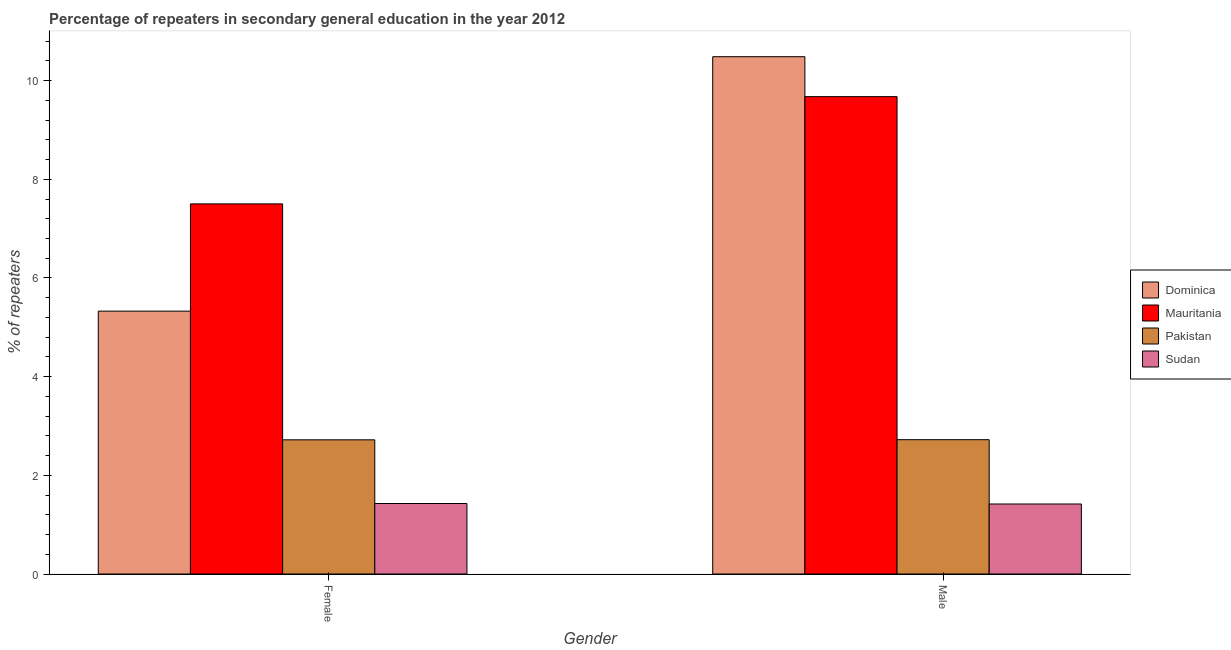How many groups of bars are there?
Give a very brief answer. 2. What is the label of the 2nd group of bars from the left?
Keep it short and to the point. Male. What is the percentage of female repeaters in Sudan?
Your answer should be compact. 1.43. Across all countries, what is the maximum percentage of male repeaters?
Make the answer very short. 10.49. Across all countries, what is the minimum percentage of female repeaters?
Provide a succinct answer. 1.43. In which country was the percentage of male repeaters maximum?
Make the answer very short. Dominica. In which country was the percentage of male repeaters minimum?
Offer a very short reply. Sudan. What is the total percentage of female repeaters in the graph?
Provide a succinct answer. 16.98. What is the difference between the percentage of female repeaters in Mauritania and that in Pakistan?
Offer a very short reply. 4.78. What is the difference between the percentage of female repeaters in Pakistan and the percentage of male repeaters in Dominica?
Offer a terse response. -7.77. What is the average percentage of female repeaters per country?
Offer a very short reply. 4.24. What is the difference between the percentage of male repeaters and percentage of female repeaters in Sudan?
Ensure brevity in your answer.  -0.01. In how many countries, is the percentage of female repeaters greater than 7.6 %?
Offer a terse response. 0. What is the ratio of the percentage of male repeaters in Pakistan to that in Sudan?
Offer a terse response. 1.92. Is the percentage of female repeaters in Mauritania less than that in Sudan?
Your answer should be compact. No. In how many countries, is the percentage of male repeaters greater than the average percentage of male repeaters taken over all countries?
Offer a very short reply. 2. What does the 1st bar from the left in Male represents?
Make the answer very short. Dominica. Are the values on the major ticks of Y-axis written in scientific E-notation?
Keep it short and to the point. No. Does the graph contain any zero values?
Make the answer very short. No. How many legend labels are there?
Give a very brief answer. 4. What is the title of the graph?
Offer a very short reply. Percentage of repeaters in secondary general education in the year 2012. What is the label or title of the X-axis?
Ensure brevity in your answer.  Gender. What is the label or title of the Y-axis?
Offer a terse response. % of repeaters. What is the % of repeaters of Dominica in Female?
Ensure brevity in your answer.  5.33. What is the % of repeaters in Mauritania in Female?
Make the answer very short. 7.5. What is the % of repeaters in Pakistan in Female?
Give a very brief answer. 2.72. What is the % of repeaters of Sudan in Female?
Provide a succinct answer. 1.43. What is the % of repeaters of Dominica in Male?
Make the answer very short. 10.49. What is the % of repeaters in Mauritania in Male?
Offer a very short reply. 9.68. What is the % of repeaters in Pakistan in Male?
Make the answer very short. 2.72. What is the % of repeaters in Sudan in Male?
Provide a short and direct response. 1.42. Across all Gender, what is the maximum % of repeaters of Dominica?
Your answer should be very brief. 10.49. Across all Gender, what is the maximum % of repeaters in Mauritania?
Ensure brevity in your answer.  9.68. Across all Gender, what is the maximum % of repeaters of Pakistan?
Your answer should be very brief. 2.72. Across all Gender, what is the maximum % of repeaters in Sudan?
Give a very brief answer. 1.43. Across all Gender, what is the minimum % of repeaters of Dominica?
Give a very brief answer. 5.33. Across all Gender, what is the minimum % of repeaters in Mauritania?
Your response must be concise. 7.5. Across all Gender, what is the minimum % of repeaters of Pakistan?
Offer a terse response. 2.72. Across all Gender, what is the minimum % of repeaters in Sudan?
Offer a very short reply. 1.42. What is the total % of repeaters in Dominica in the graph?
Give a very brief answer. 15.81. What is the total % of repeaters in Mauritania in the graph?
Your answer should be compact. 17.18. What is the total % of repeaters of Pakistan in the graph?
Your response must be concise. 5.44. What is the total % of repeaters of Sudan in the graph?
Keep it short and to the point. 2.85. What is the difference between the % of repeaters of Dominica in Female and that in Male?
Give a very brief answer. -5.16. What is the difference between the % of repeaters in Mauritania in Female and that in Male?
Your answer should be very brief. -2.17. What is the difference between the % of repeaters in Pakistan in Female and that in Male?
Your response must be concise. -0. What is the difference between the % of repeaters in Sudan in Female and that in Male?
Give a very brief answer. 0.01. What is the difference between the % of repeaters in Dominica in Female and the % of repeaters in Mauritania in Male?
Keep it short and to the point. -4.35. What is the difference between the % of repeaters of Dominica in Female and the % of repeaters of Pakistan in Male?
Your answer should be very brief. 2.61. What is the difference between the % of repeaters of Dominica in Female and the % of repeaters of Sudan in Male?
Your answer should be very brief. 3.91. What is the difference between the % of repeaters of Mauritania in Female and the % of repeaters of Pakistan in Male?
Give a very brief answer. 4.78. What is the difference between the % of repeaters of Mauritania in Female and the % of repeaters of Sudan in Male?
Offer a very short reply. 6.08. What is the difference between the % of repeaters in Pakistan in Female and the % of repeaters in Sudan in Male?
Provide a short and direct response. 1.3. What is the average % of repeaters of Dominica per Gender?
Ensure brevity in your answer.  7.91. What is the average % of repeaters in Mauritania per Gender?
Provide a succinct answer. 8.59. What is the average % of repeaters of Pakistan per Gender?
Ensure brevity in your answer.  2.72. What is the average % of repeaters of Sudan per Gender?
Offer a terse response. 1.42. What is the difference between the % of repeaters in Dominica and % of repeaters in Mauritania in Female?
Make the answer very short. -2.17. What is the difference between the % of repeaters of Dominica and % of repeaters of Pakistan in Female?
Keep it short and to the point. 2.61. What is the difference between the % of repeaters of Dominica and % of repeaters of Sudan in Female?
Offer a very short reply. 3.9. What is the difference between the % of repeaters in Mauritania and % of repeaters in Pakistan in Female?
Make the answer very short. 4.78. What is the difference between the % of repeaters in Mauritania and % of repeaters in Sudan in Female?
Give a very brief answer. 6.07. What is the difference between the % of repeaters in Pakistan and % of repeaters in Sudan in Female?
Your answer should be compact. 1.29. What is the difference between the % of repeaters of Dominica and % of repeaters of Mauritania in Male?
Give a very brief answer. 0.81. What is the difference between the % of repeaters of Dominica and % of repeaters of Pakistan in Male?
Keep it short and to the point. 7.76. What is the difference between the % of repeaters of Dominica and % of repeaters of Sudan in Male?
Give a very brief answer. 9.07. What is the difference between the % of repeaters of Mauritania and % of repeaters of Pakistan in Male?
Your answer should be very brief. 6.95. What is the difference between the % of repeaters of Mauritania and % of repeaters of Sudan in Male?
Give a very brief answer. 8.26. What is the difference between the % of repeaters in Pakistan and % of repeaters in Sudan in Male?
Your answer should be very brief. 1.3. What is the ratio of the % of repeaters in Dominica in Female to that in Male?
Your response must be concise. 0.51. What is the ratio of the % of repeaters of Mauritania in Female to that in Male?
Offer a very short reply. 0.78. What is the ratio of the % of repeaters of Sudan in Female to that in Male?
Offer a terse response. 1.01. What is the difference between the highest and the second highest % of repeaters in Dominica?
Your answer should be very brief. 5.16. What is the difference between the highest and the second highest % of repeaters in Mauritania?
Provide a succinct answer. 2.17. What is the difference between the highest and the second highest % of repeaters of Pakistan?
Give a very brief answer. 0. What is the difference between the highest and the second highest % of repeaters in Sudan?
Keep it short and to the point. 0.01. What is the difference between the highest and the lowest % of repeaters in Dominica?
Ensure brevity in your answer.  5.16. What is the difference between the highest and the lowest % of repeaters of Mauritania?
Give a very brief answer. 2.17. What is the difference between the highest and the lowest % of repeaters in Pakistan?
Provide a succinct answer. 0. What is the difference between the highest and the lowest % of repeaters in Sudan?
Your response must be concise. 0.01. 